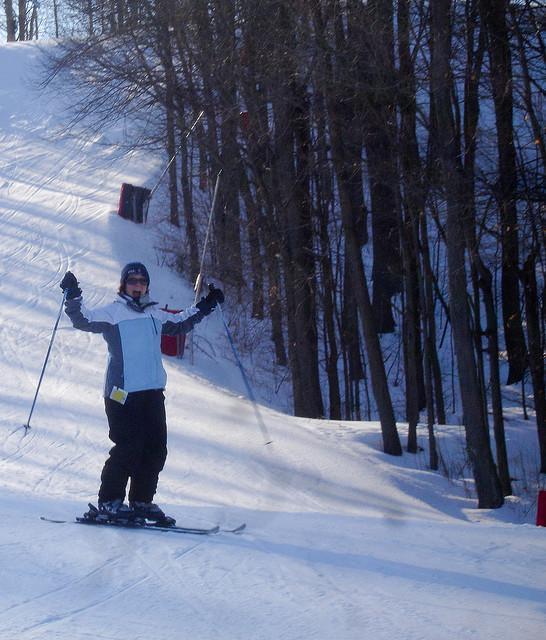How many people are in the picture?
Give a very brief answer. 1. How many train cars are behind the locomotive?
Give a very brief answer. 0. 